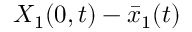<formula> <loc_0><loc_0><loc_500><loc_500>X _ { 1 } ( 0 , t ) - \bar { x } _ { 1 } ( t )</formula> 